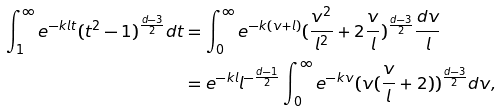<formula> <loc_0><loc_0><loc_500><loc_500>\int _ { 1 } ^ { \infty } e ^ { - k l t } ( t ^ { 2 } - 1 ) ^ { \frac { d - 3 } { 2 } } d t & = \int _ { 0 } ^ { \infty } e ^ { - k ( v + l ) } ( \frac { v ^ { 2 } } { l ^ { 2 } } + 2 \frac { v } { l } ) ^ { \frac { d - 3 } { 2 } } \frac { d v } l \\ & = e ^ { - k l } l ^ { - \frac { d - 1 } 2 } \int _ { 0 } ^ { \infty } e ^ { - k v } ( v ( \frac { v } { l } + 2 ) ) ^ { \frac { d - 3 } { 2 } } d v ,</formula> 